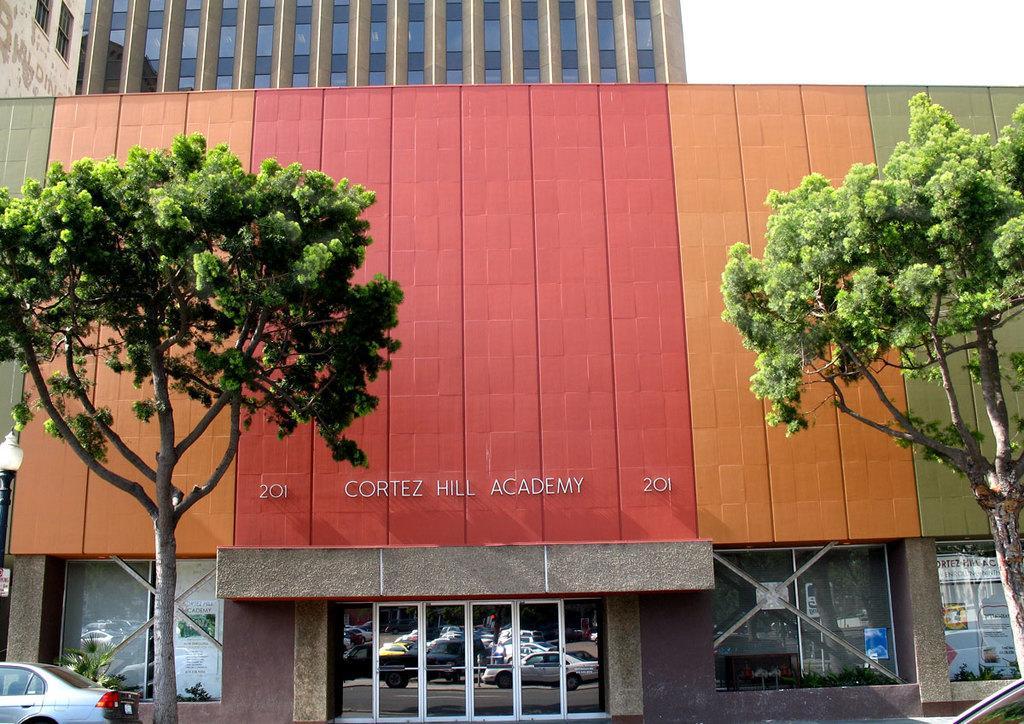How would you summarize this image in a sentence or two? This image is taken outdoors. In the background there are two buildings. In the middle of the image there is a building with walls, doors and windows. There are a few posters with text on them. There is a text on the wall. On the left side of the image a car is parked on the ground. There is a tree and there is a plant. There is a pole with a street light. On the right side of the image there is a tree. 